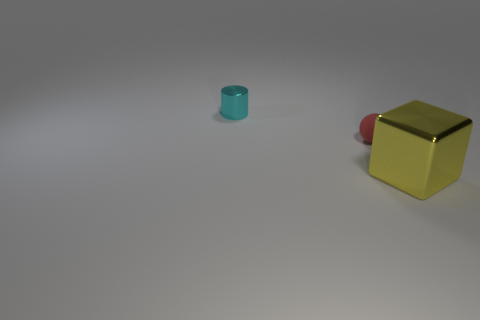Add 1 large yellow metal objects. How many objects exist? 4 Subtract all cubes. How many objects are left? 2 Add 3 cyan metallic things. How many cyan metallic things are left? 4 Add 3 big cubes. How many big cubes exist? 4 Subtract 0 brown cylinders. How many objects are left? 3 Subtract all large purple blocks. Subtract all tiny red things. How many objects are left? 2 